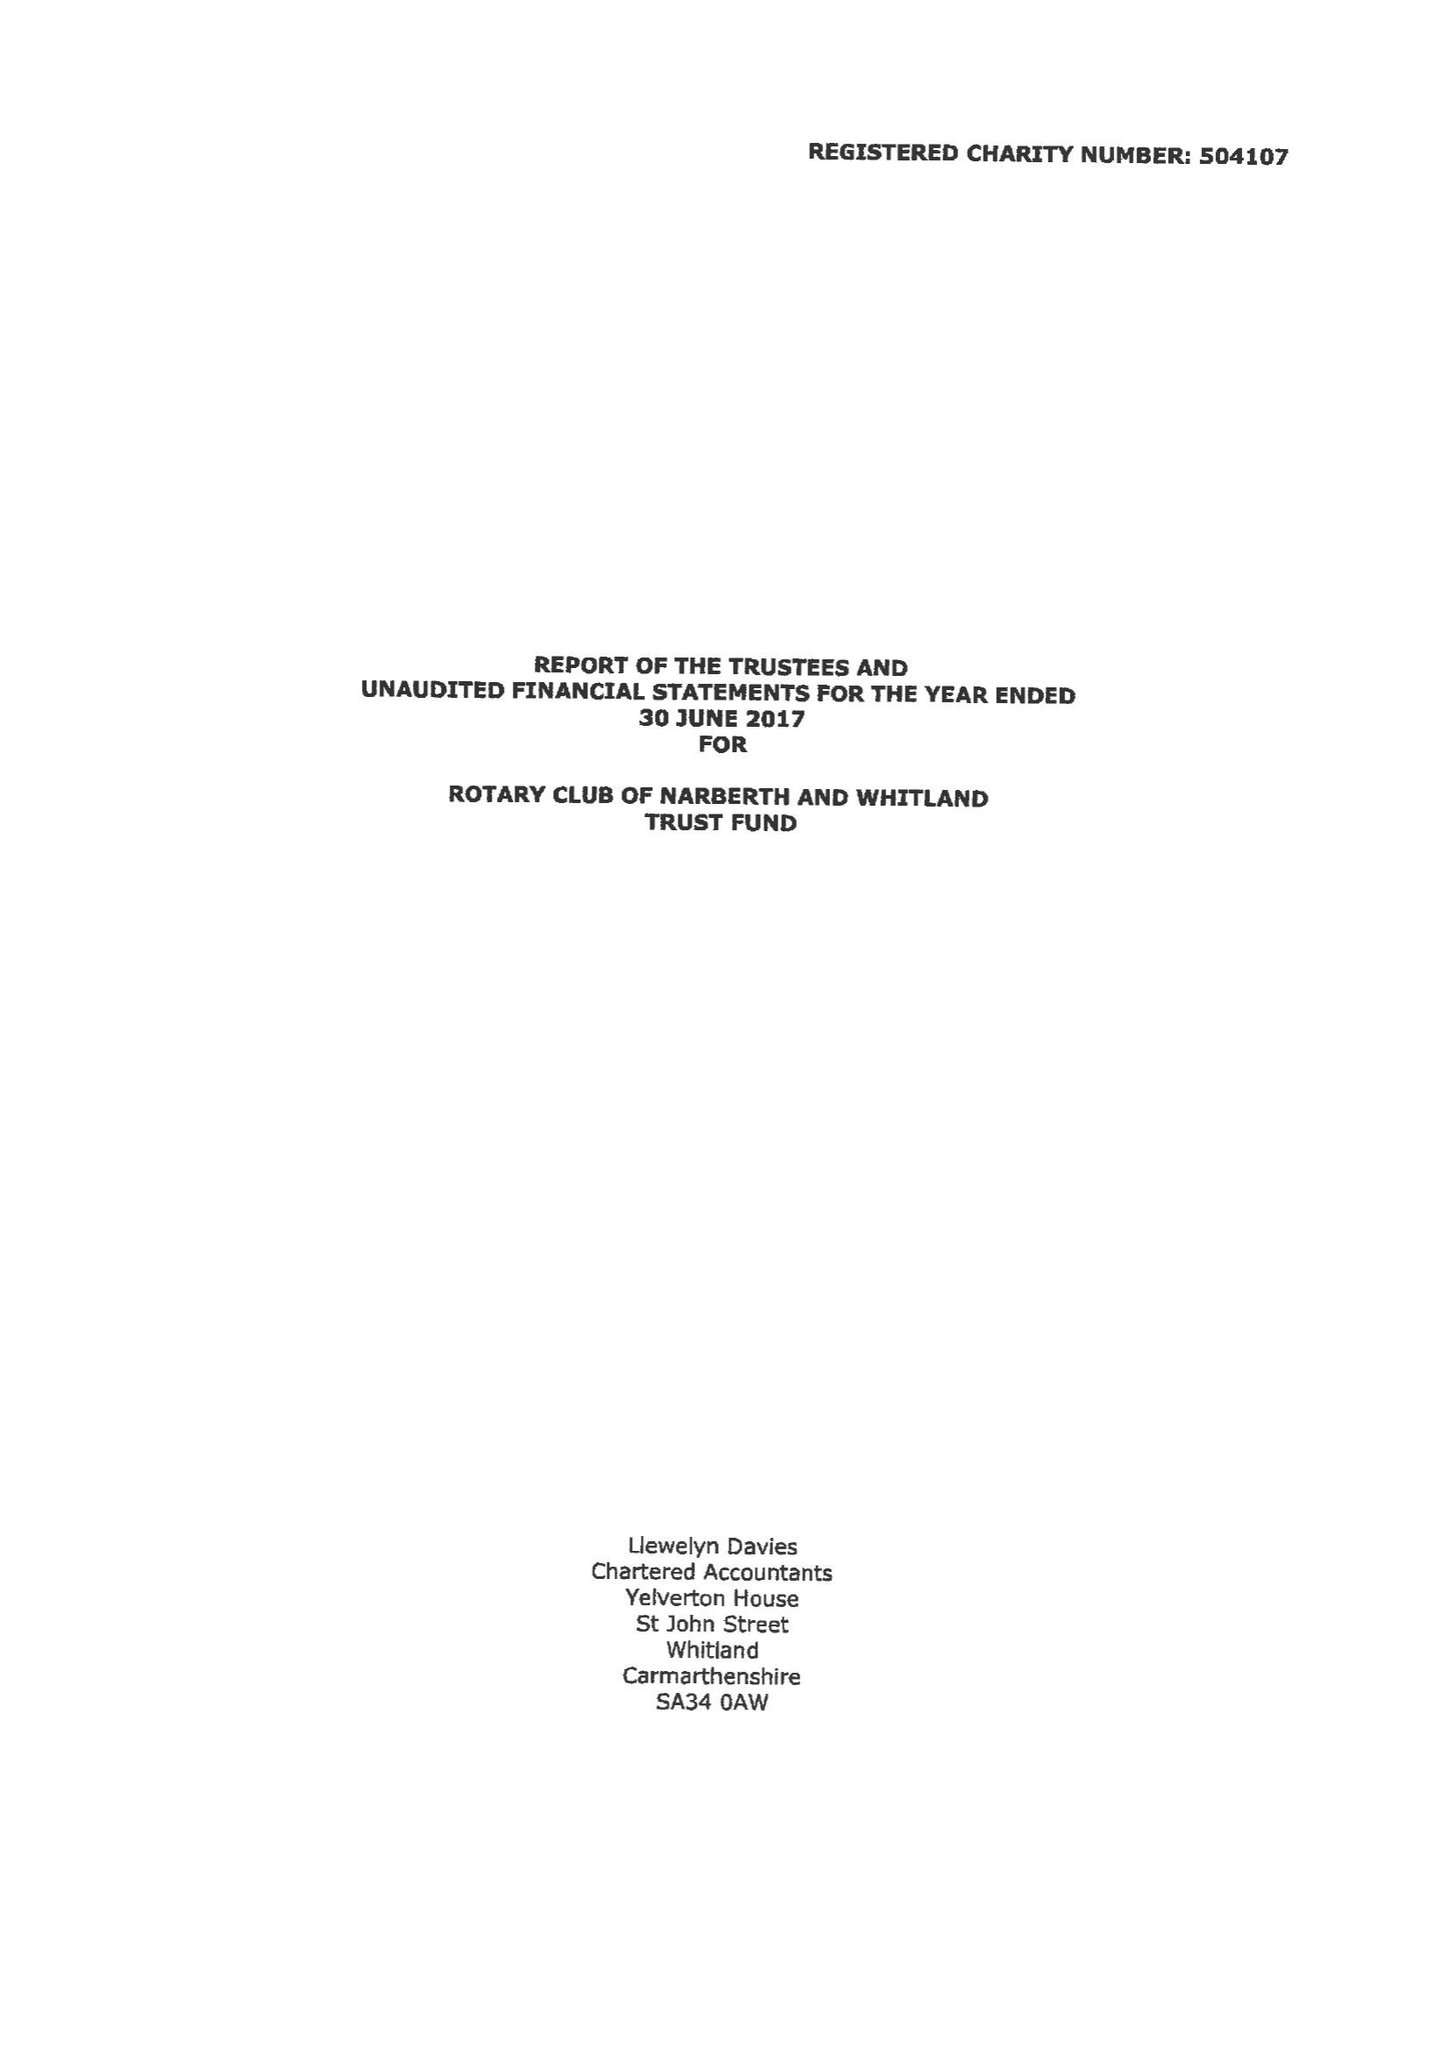What is the value for the spending_annually_in_british_pounds?
Answer the question using a single word or phrase. 41407.00 